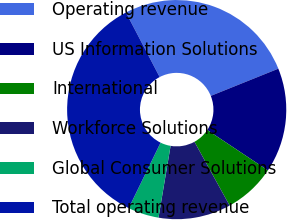Convert chart. <chart><loc_0><loc_0><loc_500><loc_500><pie_chart><fcel>Operating revenue<fcel>US Information Solutions<fcel>International<fcel>Workforce Solutions<fcel>Global Consumer Solutions<fcel>Total operating revenue<nl><fcel>26.57%<fcel>15.45%<fcel>7.62%<fcel>10.68%<fcel>4.56%<fcel>35.12%<nl></chart> 